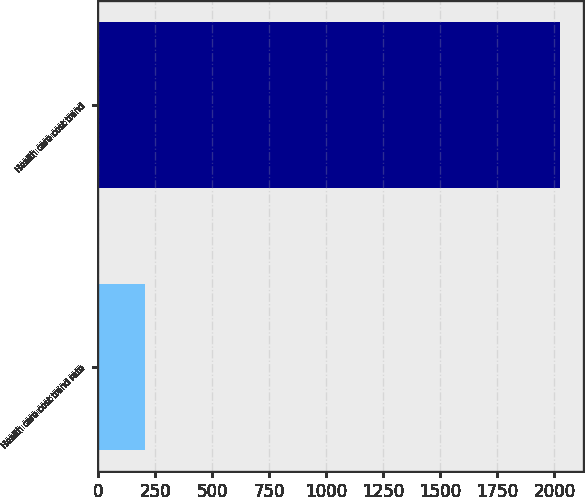<chart> <loc_0><loc_0><loc_500><loc_500><bar_chart><fcel>Health care cost trend rate<fcel>Health care cost trend<nl><fcel>207.1<fcel>2026<nl></chart> 